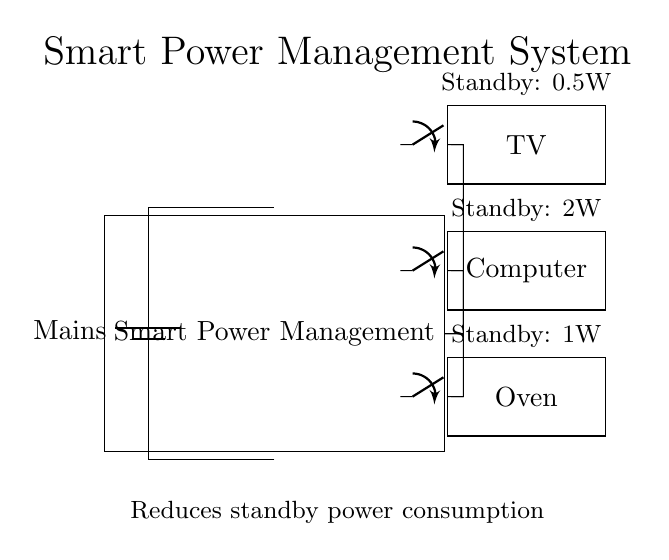What type of system is shown in the circuit? The circuit depicts a Smart Power Management system, which is designed to control power consumption of connected appliances. This is indicated by the labeled component in the diagram.
Answer: Smart Power Management How many appliances are connected to the smart power management system? The circuit diagram shows three appliances: a TV, a Computer, and an Oven. Each appliance is represented by a labeled rectangle in the diagram.
Answer: Three What is the standby power consumption of the TV? The diagram notes that the standby power consumption of the TV is 0.5W, as shown in the label directly above the TV component.
Answer: 0.5W Which appliance has the highest standby power consumption? The Computer has the highest standby power consumption at 2W, as stated in the label above the Computer component, compared to the other appliances.
Answer: Computer How is power supplied to the appliances? Power is supplied from the mains, as indicated by the battery symbol at the top of the circuit diagram, which connects to the Smart Power Management system.
Answer: Mains What is the purpose of the switches in the circuit? The switches allow individual control of each appliance's connection to the Smart Power Management system, enabling the user to turn appliances on or off to reduce standby consumption. Each switch is positioned next to its corresponding appliance.
Answer: Control What is the maximum standby power consumption of all connected appliances? To find the maximum standby power, sum the standby power of all appliances: 0.5W (TV) + 2W (Computer) + 1W (Oven) = 3.5W. This calculation considers all listed standby consumption values for each appliance in the diagram.
Answer: 3.5W 